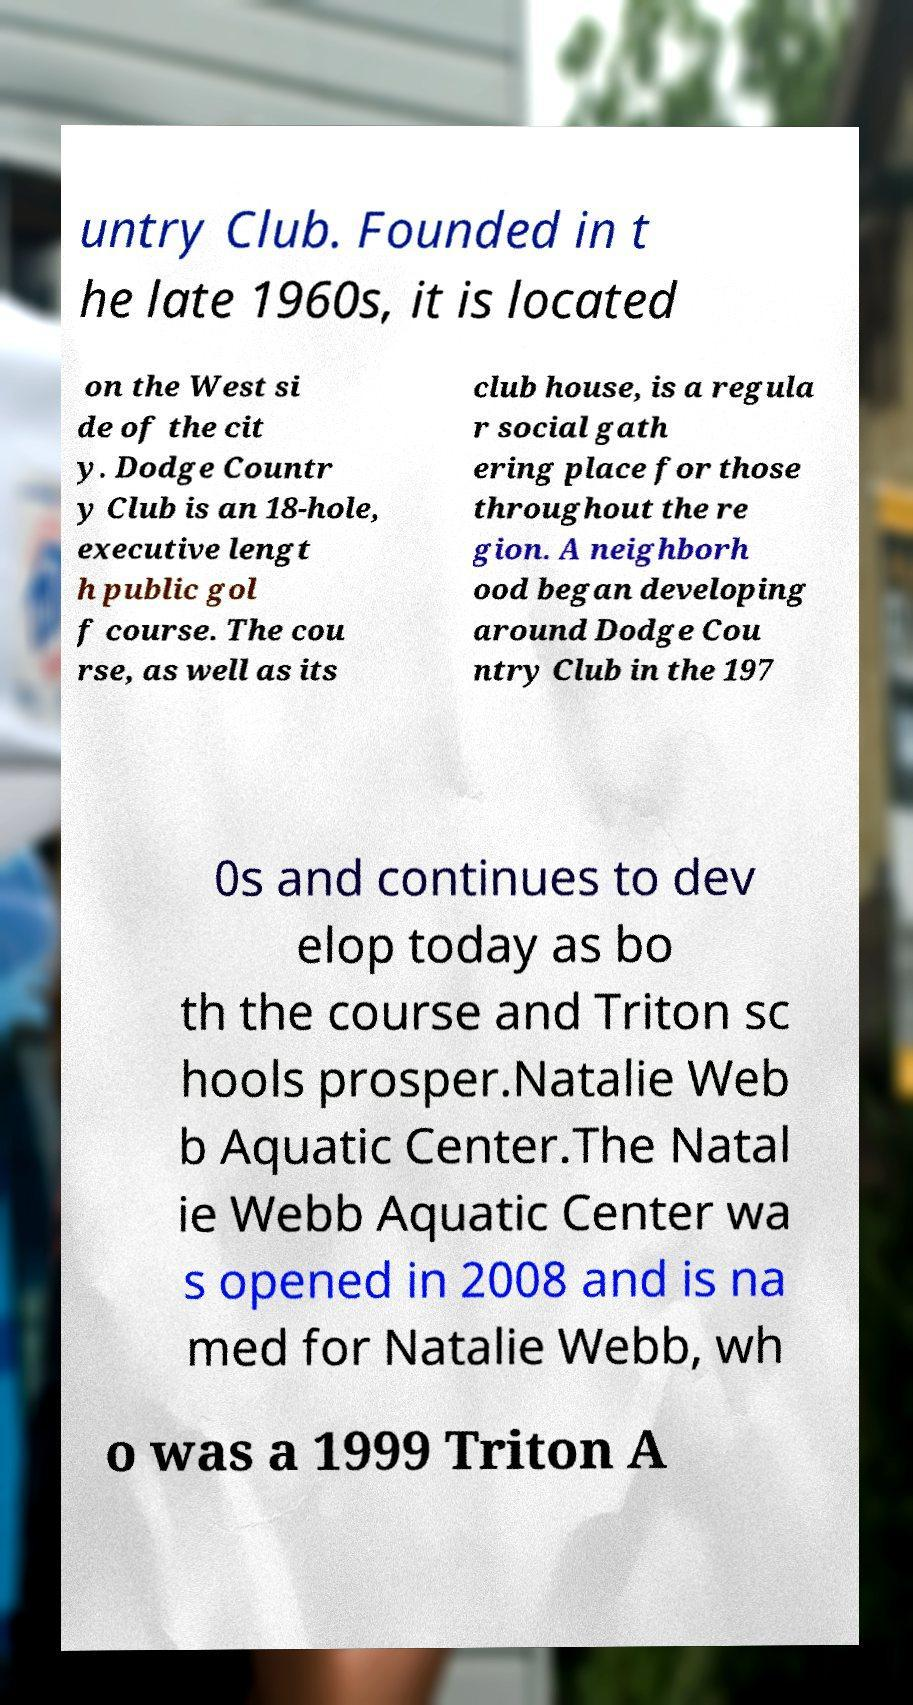Could you assist in decoding the text presented in this image and type it out clearly? untry Club. Founded in t he late 1960s, it is located on the West si de of the cit y. Dodge Countr y Club is an 18-hole, executive lengt h public gol f course. The cou rse, as well as its club house, is a regula r social gath ering place for those throughout the re gion. A neighborh ood began developing around Dodge Cou ntry Club in the 197 0s and continues to dev elop today as bo th the course and Triton sc hools prosper.Natalie Web b Aquatic Center.The Natal ie Webb Aquatic Center wa s opened in 2008 and is na med for Natalie Webb, wh o was a 1999 Triton A 